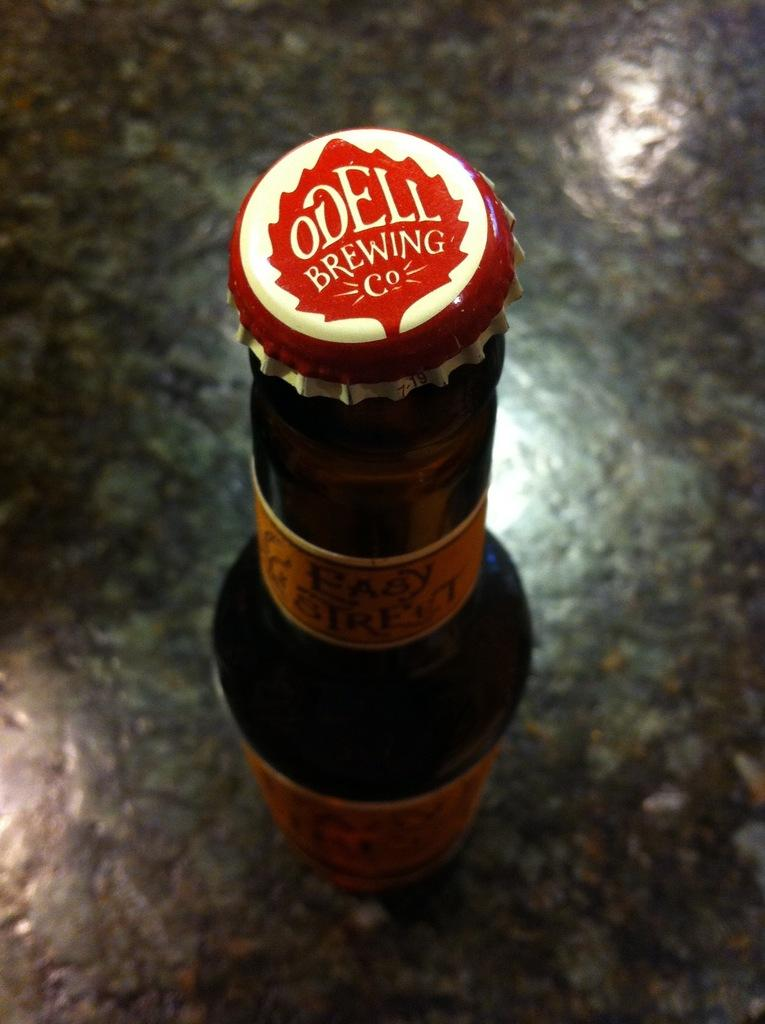Provide a one-sentence caption for the provided image. Bottle of beer with a red cap that says "Odell Brewing Co". 